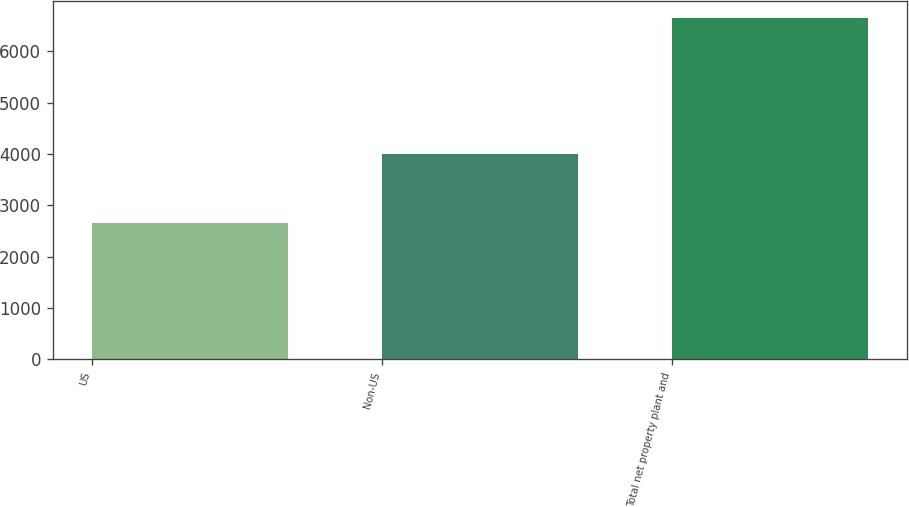Convert chart to OTSL. <chart><loc_0><loc_0><loc_500><loc_500><bar_chart><fcel>US<fcel>Non-US<fcel>Total net property plant and<nl><fcel>2648<fcel>4001<fcel>6649<nl></chart> 